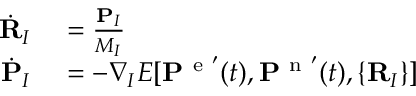<formula> <loc_0><loc_0><loc_500><loc_500>\begin{array} { r l } { \dot { R } _ { I } } & = \frac { P _ { I } } { M _ { I } } } \\ { \dot { P } _ { I } } & = - \nabla _ { I } E [ P ^ { e ^ { \prime } } ( t ) , P ^ { n ^ { \prime } } ( t ) , \{ R _ { I } \} ] } \end{array}</formula> 